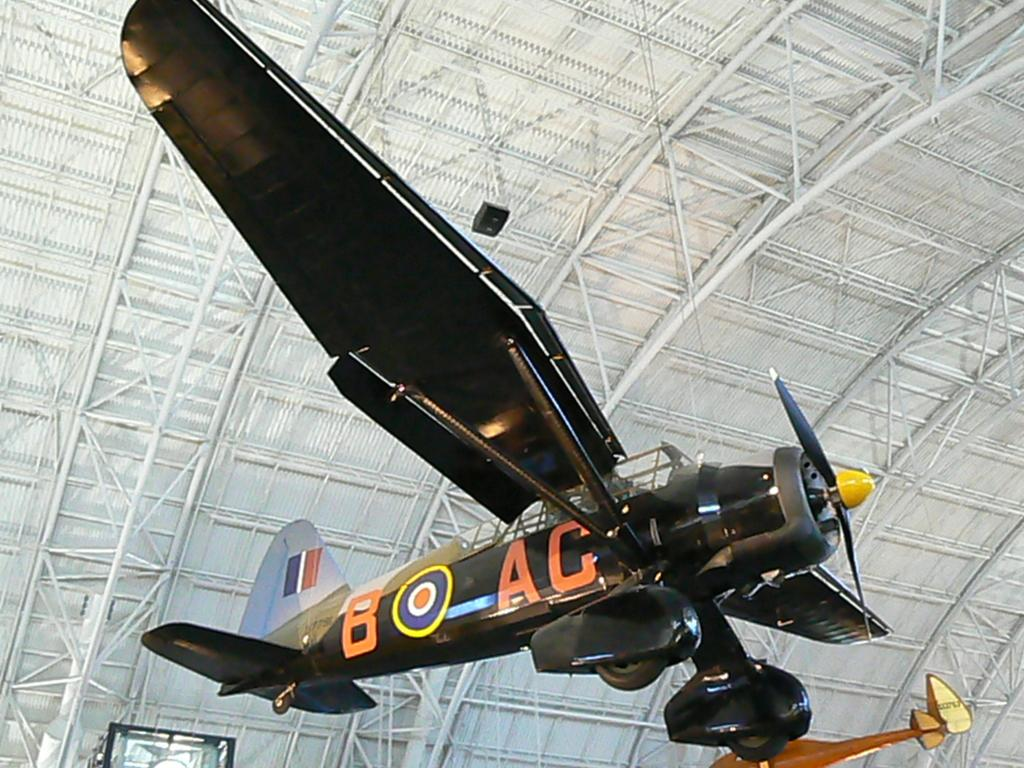<image>
Describe the image concisely. A plane with BO AC written on the side of it is suspended in the air 